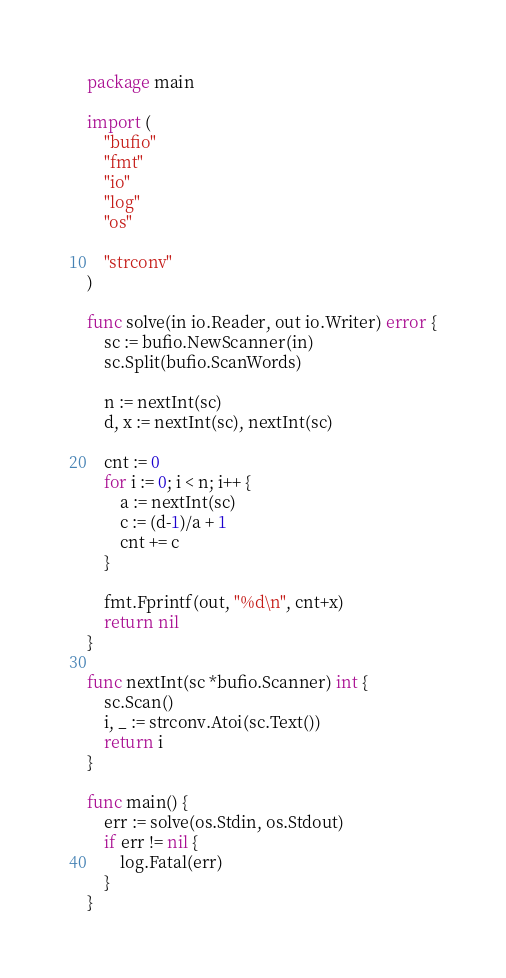<code> <loc_0><loc_0><loc_500><loc_500><_Go_>package main

import (
	"bufio"
	"fmt"
	"io"
	"log"
	"os"

	"strconv"
)

func solve(in io.Reader, out io.Writer) error {
	sc := bufio.NewScanner(in)
	sc.Split(bufio.ScanWords)

	n := nextInt(sc)
	d, x := nextInt(sc), nextInt(sc)

	cnt := 0
	for i := 0; i < n; i++ {
		a := nextInt(sc)
		c := (d-1)/a + 1
		cnt += c
	}

	fmt.Fprintf(out, "%d\n", cnt+x)
	return nil
}

func nextInt(sc *bufio.Scanner) int {
	sc.Scan()
	i, _ := strconv.Atoi(sc.Text())
	return i
}

func main() {
	err := solve(os.Stdin, os.Stdout)
	if err != nil {
		log.Fatal(err)
	}
}
</code> 